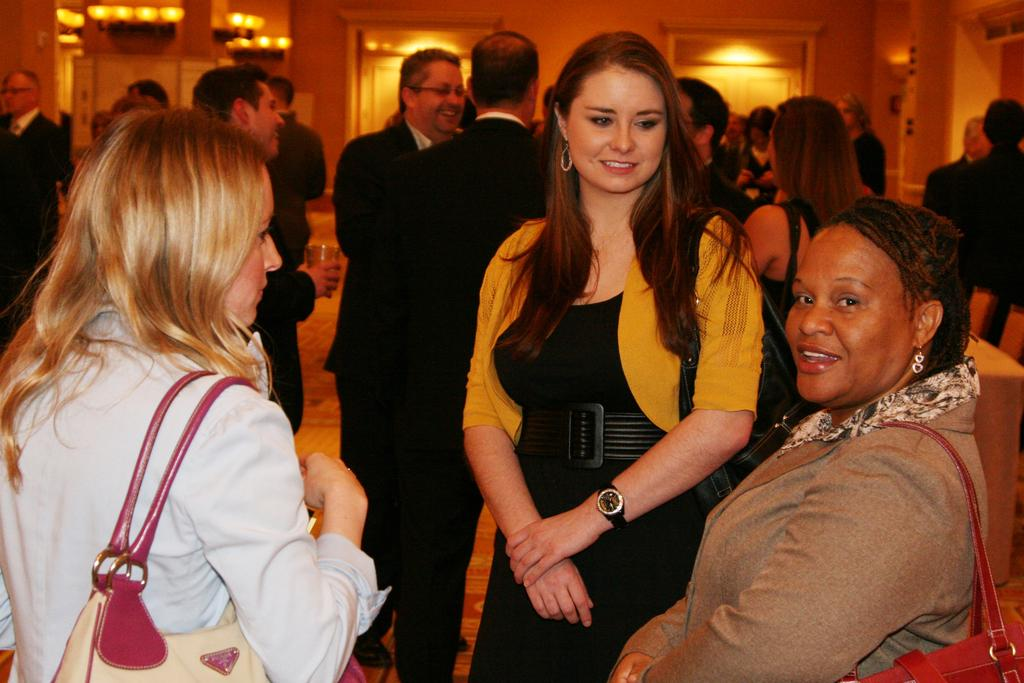How many people are in the group shown in the image? There is a group of people in the image. What are the people wearing that are relevant to the image? Three persons in the group are wearing bags. What object is being held by one person in the group? One person is holding a glass. What can be seen in the background of the image? There is a wall and lights visible in the background. What type of circle is being discussed by the group in the image? There is no circle being discussed by the group in the image. What idea is the group trying to organize in the image? There is no indication in the image that the group is discussing or organizing an idea. 